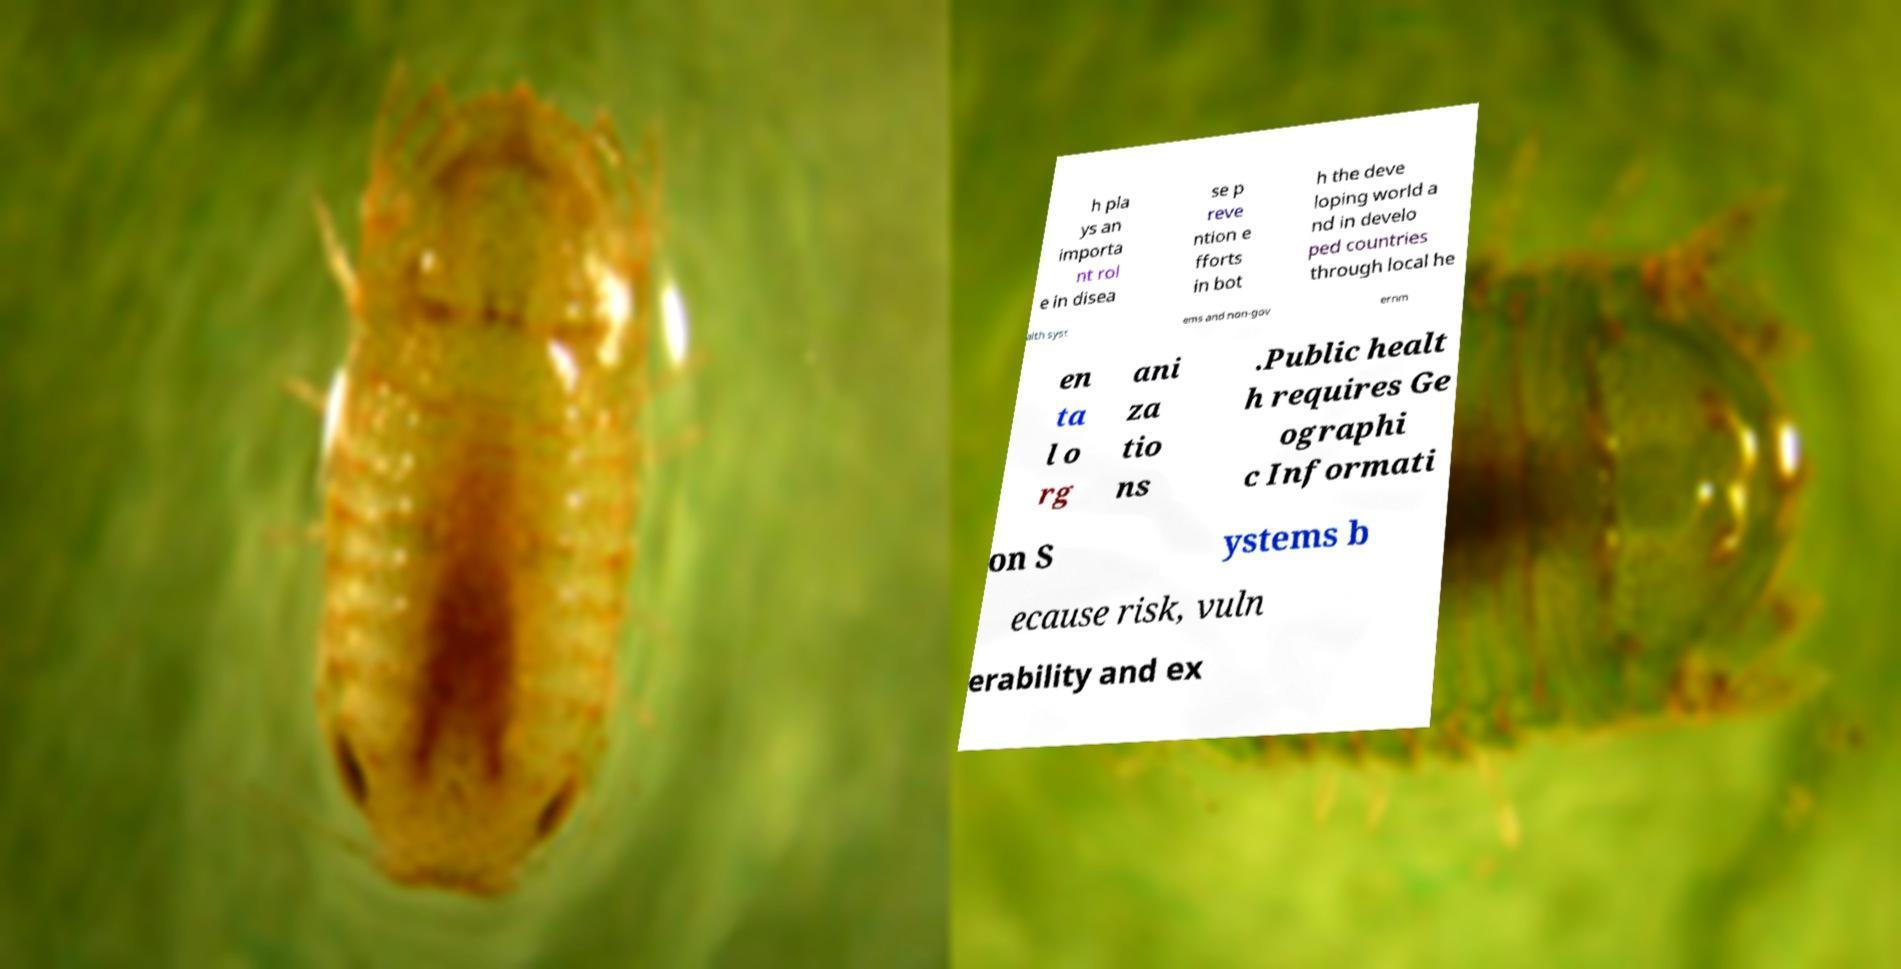Could you assist in decoding the text presented in this image and type it out clearly? h pla ys an importa nt rol e in disea se p reve ntion e fforts in bot h the deve loping world a nd in develo ped countries through local he alth syst ems and non-gov ernm en ta l o rg ani za tio ns .Public healt h requires Ge ographi c Informati on S ystems b ecause risk, vuln erability and ex 